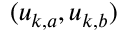<formula> <loc_0><loc_0><loc_500><loc_500>( u _ { k , a } , u _ { k , b } )</formula> 